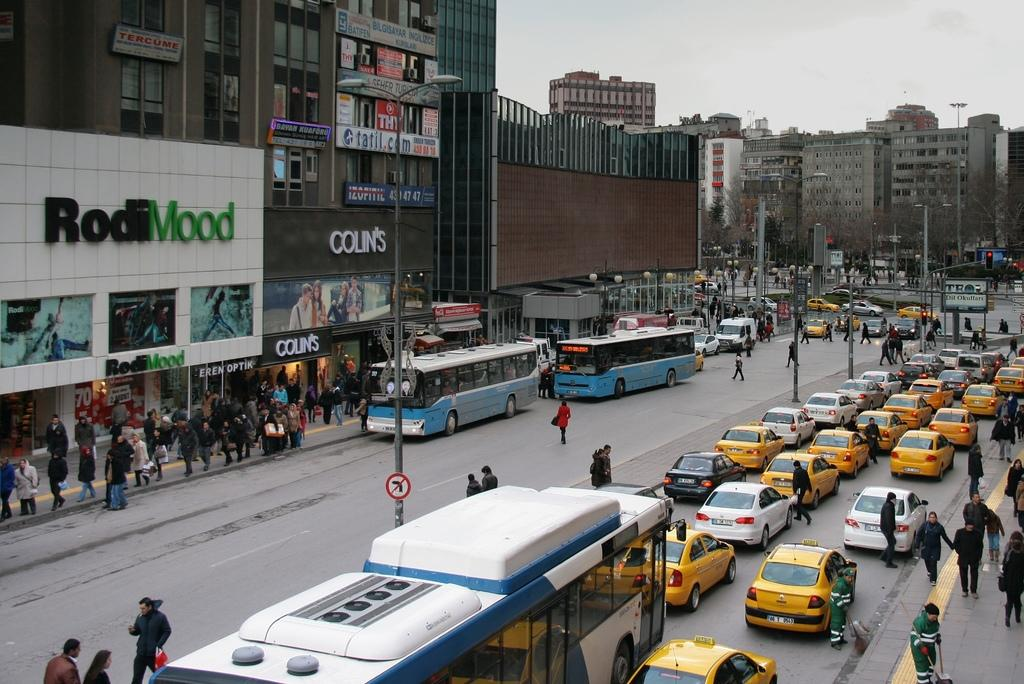Provide a one-sentence caption for the provided image. A busy street filled with cars and people in front of a shop called Rodimmood. 